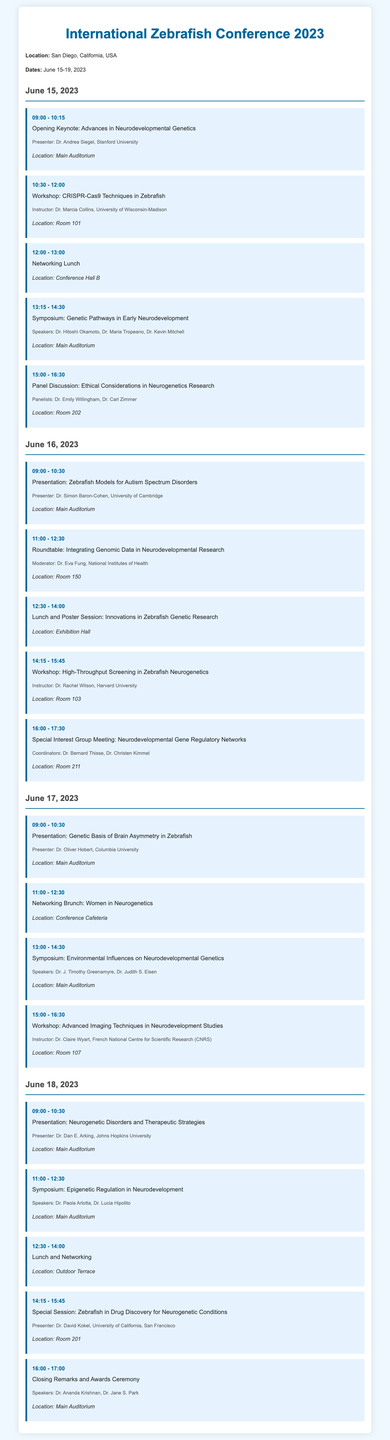What is the location of the conference? The document specifies that the location of the conference is San Diego, California, USA.
Answer: San Diego, California, USA Who is the presenter of the opening keynote? The opening keynote is presented by Dr. Andrea Siegel from Stanford University.
Answer: Dr. Andrea Siegel What time does the workshop on CRISPR-Cas9 techniques start? The workshop on CRISPR-Cas9 techniques starts at 10:30 AM on June 15, 2023.
Answer: 10:30 How many speakers are in the symposium on genetic pathways in early neurodevelopment? The symposium features three speakers: Dr. Hitoshi Okamoto, Dr. Maria Tropeano, and Dr. Kevin Mitchell.
Answer: Three Which day includes a networking brunch for women in neurogenetics? The networking brunch for women in neurogenetics takes place on June 17, 2023.
Answer: June 17, 2023 What is the theme of the special interest group meeting on June 16? The special interest group meeting focuses on Neurodevelopmental Gene Regulatory Networks.
Answer: Neurodevelopmental Gene Regulatory Networks What is the last event of the conference? The last event of the conference is the Closing Remarks and Awards Ceremony.
Answer: Closing Remarks and Awards Ceremony Who presents on neurogenetic disorders and therapeutic strategies? The presentation on neurogenetic disorders and therapeutic strategies is given by Dr. Dan E. Arking from Johns Hopkins University.
Answer: Dr. Dan E. Arking What is the purpose of the lunch on June 16? The lunch on June 16 serves as both a lunch and poster session for innovations in zebrafish genetic research.
Answer: Innovations in Zebrafish Genetic Research 